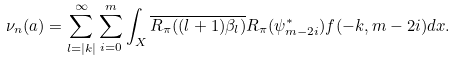Convert formula to latex. <formula><loc_0><loc_0><loc_500><loc_500>\nu _ { n } ( a ) = \sum _ { l = | k | } ^ { \infty } \sum _ { i = 0 } ^ { m } \int _ { X } \overline { R _ { \pi } ( ( l + 1 ) \beta _ { l } ) } R _ { \pi } ( \psi _ { m - 2 i } ^ { * } ) f ( - k , m - 2 i ) d x .</formula> 